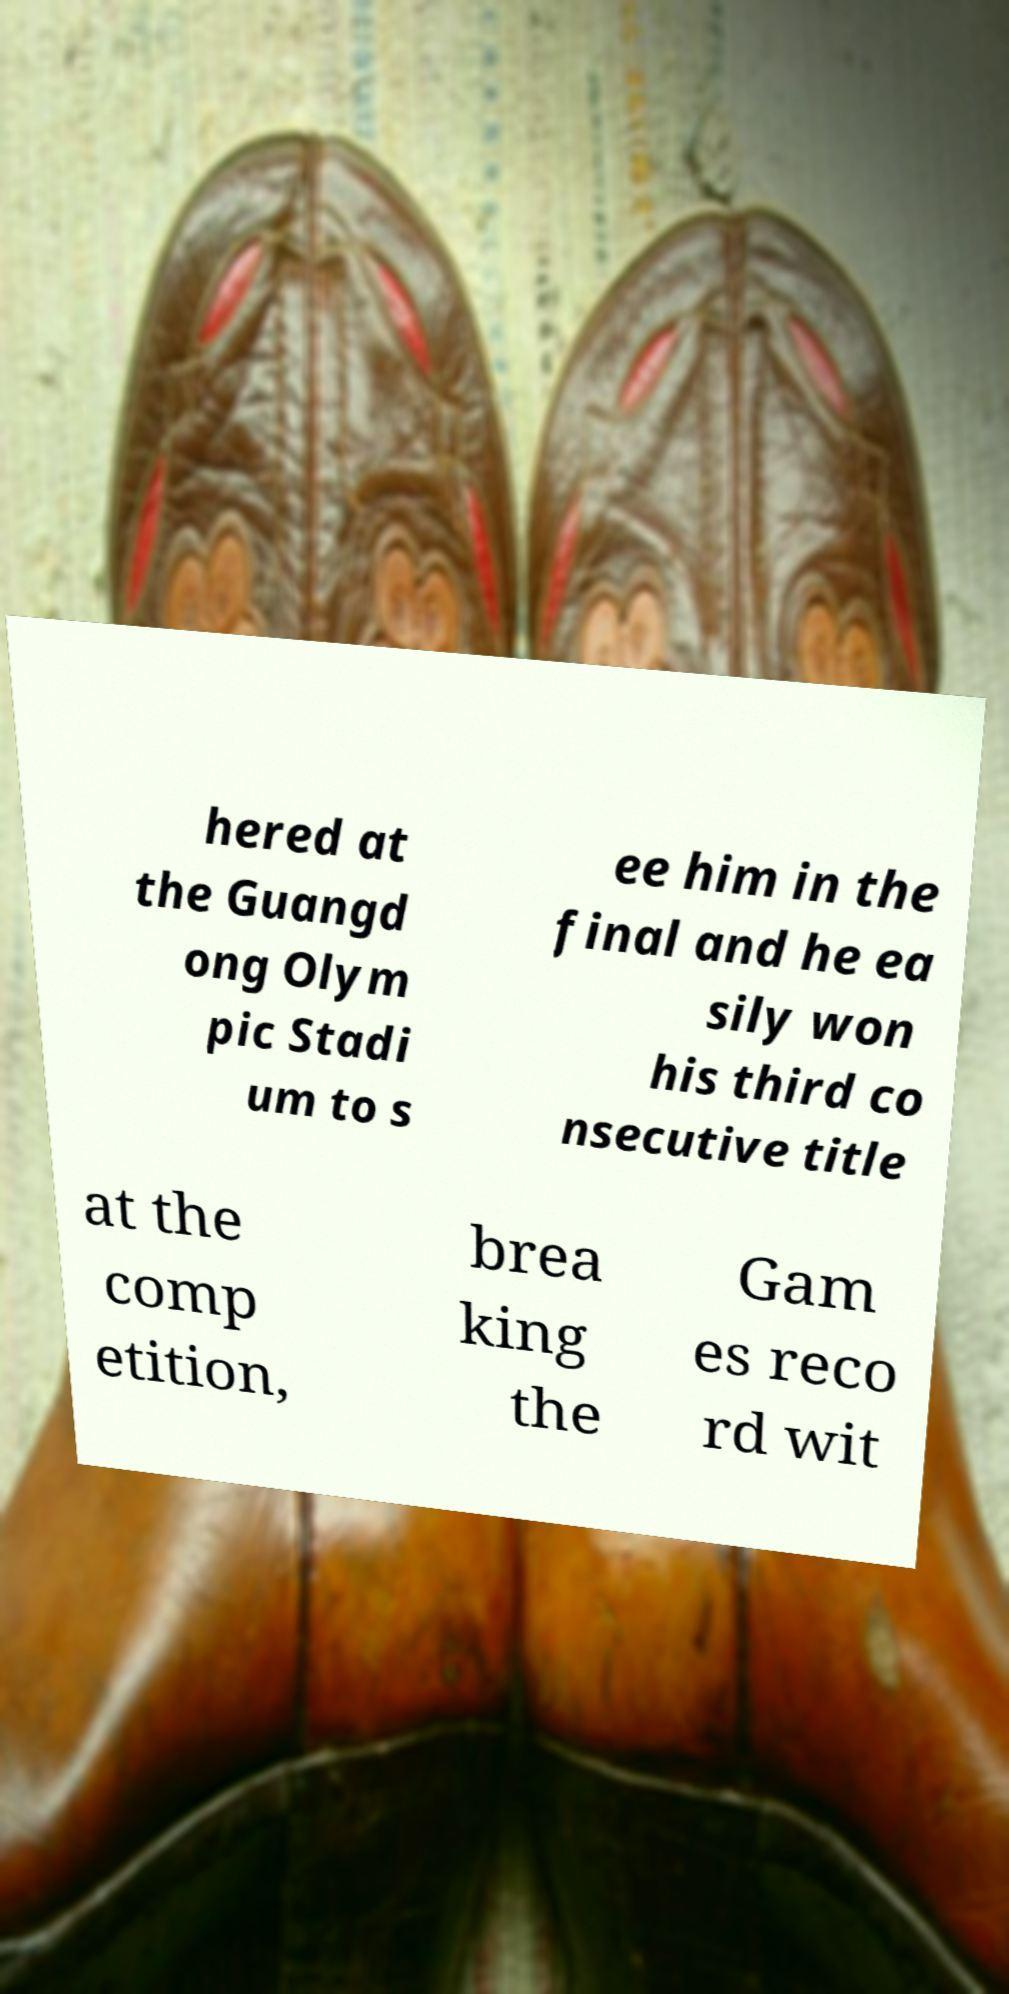Can you read and provide the text displayed in the image?This photo seems to have some interesting text. Can you extract and type it out for me? hered at the Guangd ong Olym pic Stadi um to s ee him in the final and he ea sily won his third co nsecutive title at the comp etition, brea king the Gam es reco rd wit 